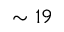<formula> <loc_0><loc_0><loc_500><loc_500>\sim 1 9</formula> 